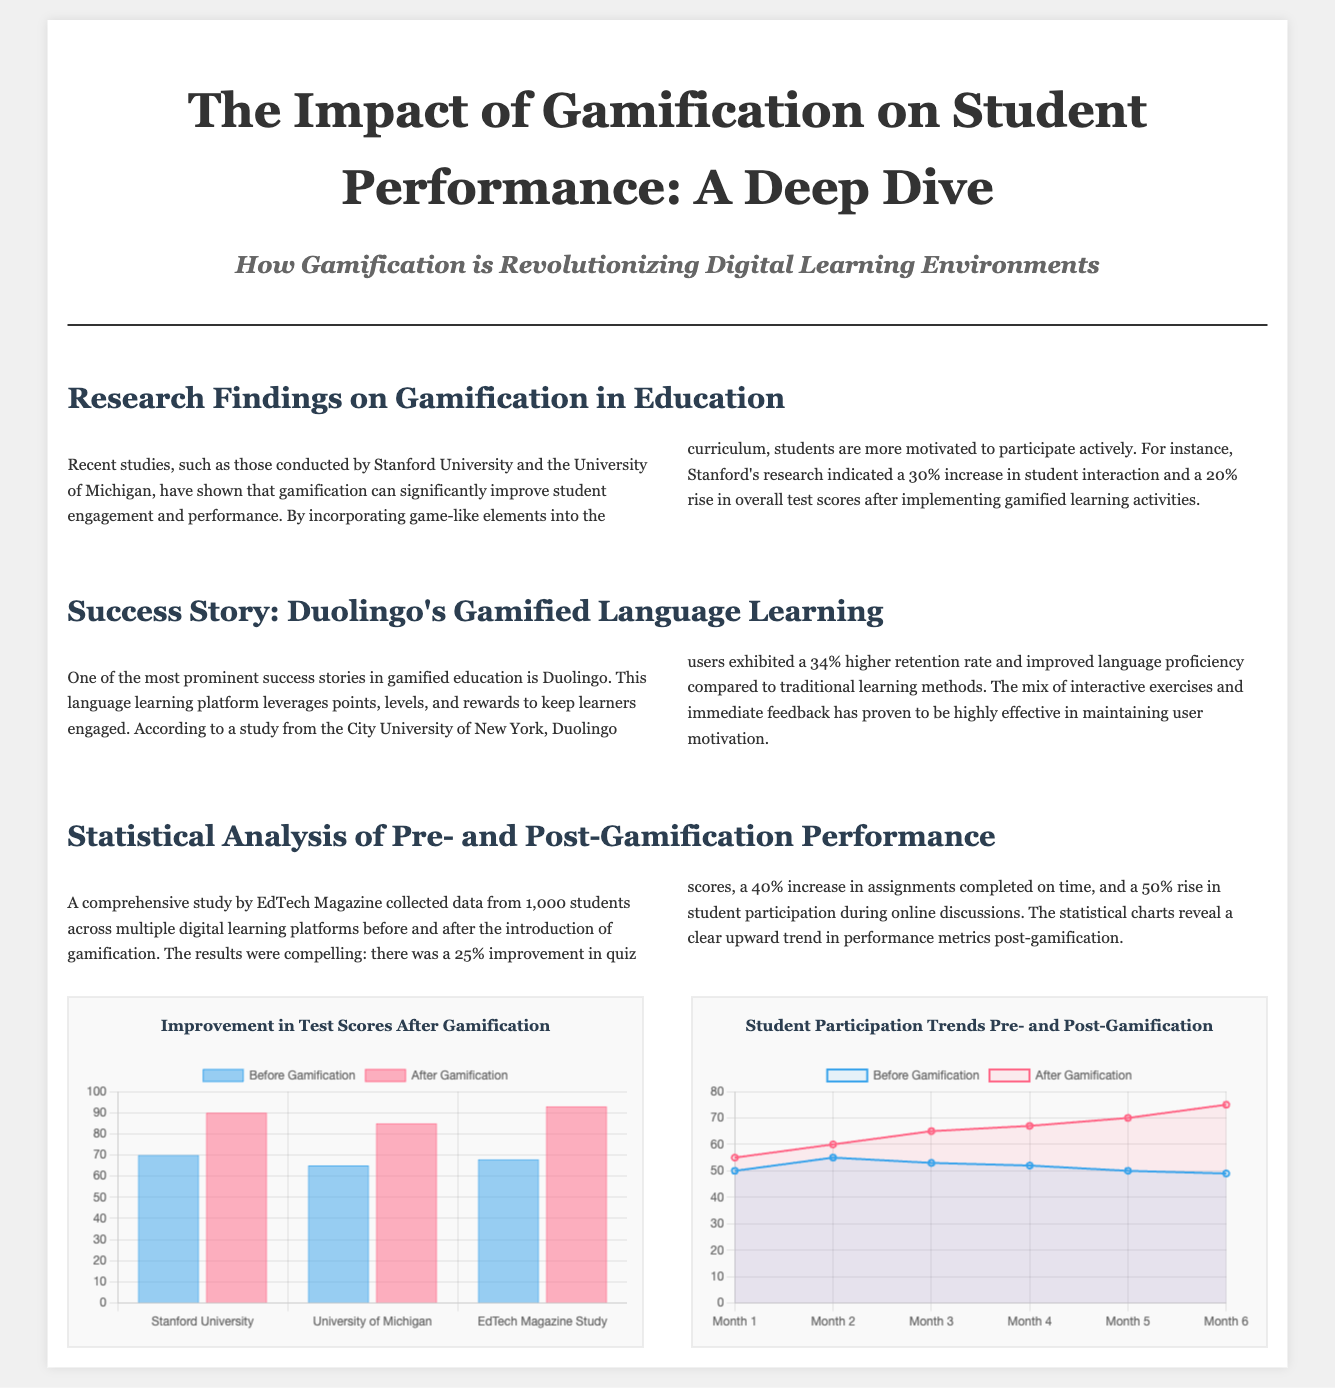What was the increase in student interaction as reported by Stanford's research? According to the research findings, Stanford reported a 30% increase in student interaction after gamification.
Answer: 30% What is the name of the language learning platform mentioned as a success story? The article highlights Duolingo as a prominent success story in gamified education.
Answer: Duolingo What percentage improvement in quiz scores was observed after gamification according to EdTech Magazine? The study by EdTech Magazine found a 25% improvement in quiz scores after gamification.
Answer: 25% What was the student retention rate increase for Duolingo users compared to traditional methods? The study indicated that Duolingo users exhibited a 34% higher retention rate compared to traditional learning methods.
Answer: 34% What type of chart is used to show the improvement in test scores after gamification? The document specifies that a bar chart is used to display the improvement in test scores.
Answer: Bar chart What did the article suggest about the overall impact of gamification on student performance? The document suggests that gamification significantly improves student engagement and performance metrics across different studies.
Answer: Significantly improves How many students were involved in the comprehensive study by EdTech Magazine on gamification? The study collected data from 1,000 students focused on gamification effects in digital learning environments.
Answer: 1,000 students What notable element increases user motivation in Duolingo's approach? Duolingo's use of points, levels, and rewards are noted as elements that significantly enhance user motivation.
Answer: Points, levels, and rewards What is the main focus of the article titled "The Impact of Gamification on Student Performance: A Deep Dive"? The article mainly focuses on how gamification is revolutionizing digital learning environments to improve student performance.
Answer: Revolutionizing digital learning environments 